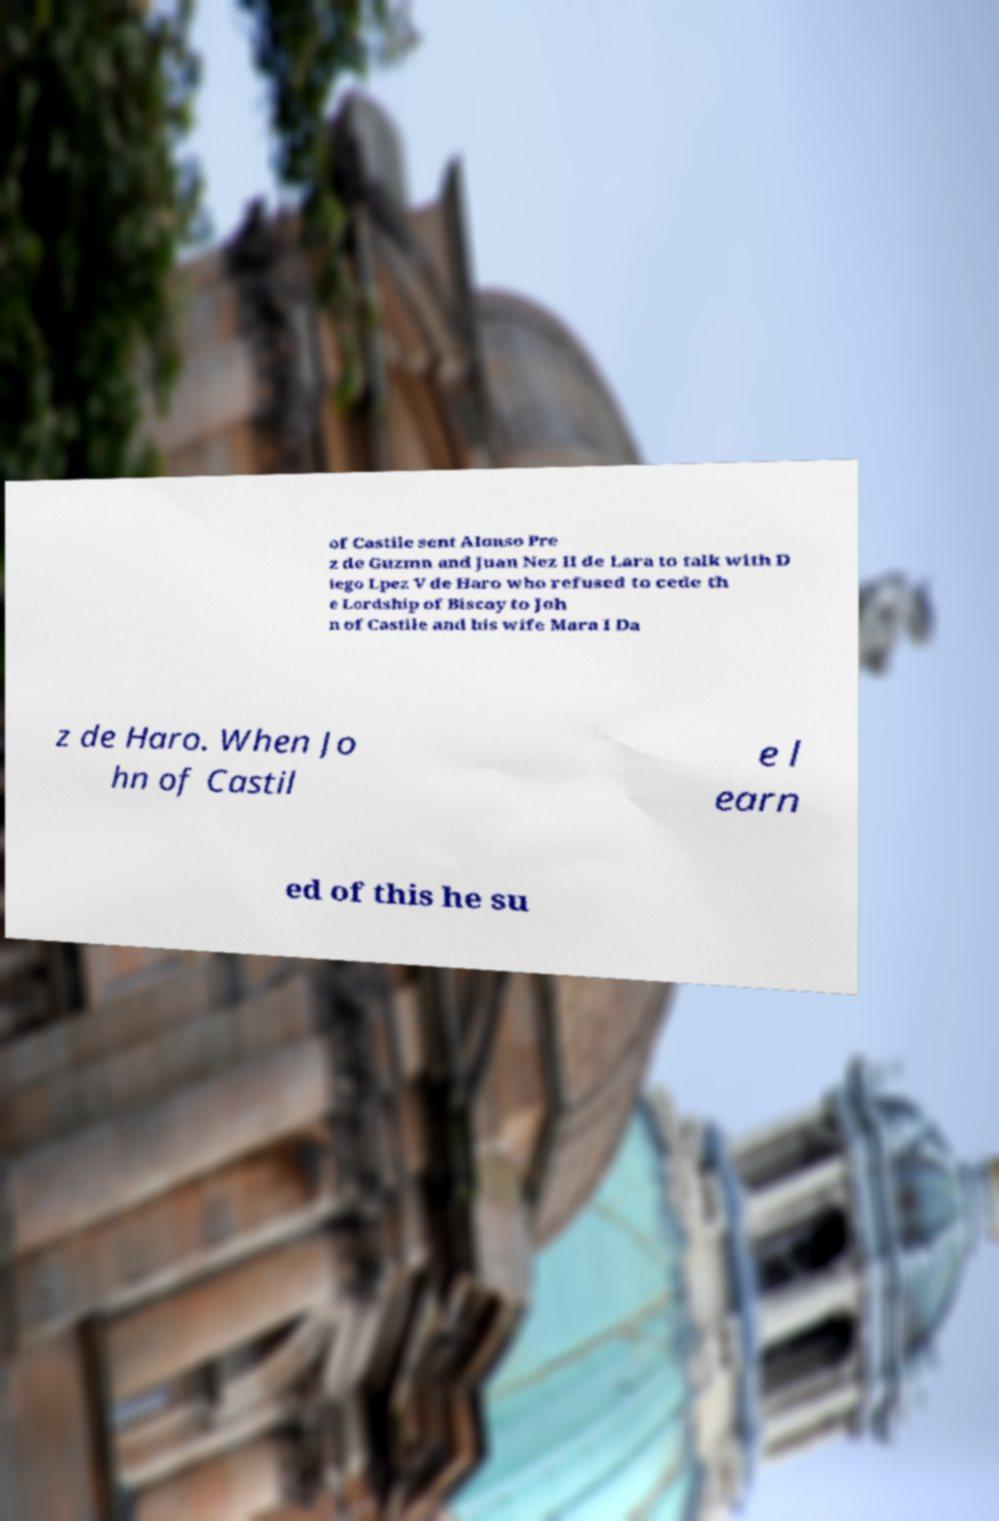For documentation purposes, I need the text within this image transcribed. Could you provide that? of Castile sent Alonso Pre z de Guzmn and Juan Nez II de Lara to talk with D iego Lpez V de Haro who refused to cede th e Lordship of Biscay to Joh n of Castile and his wife Mara I Da z de Haro. When Jo hn of Castil e l earn ed of this he su 